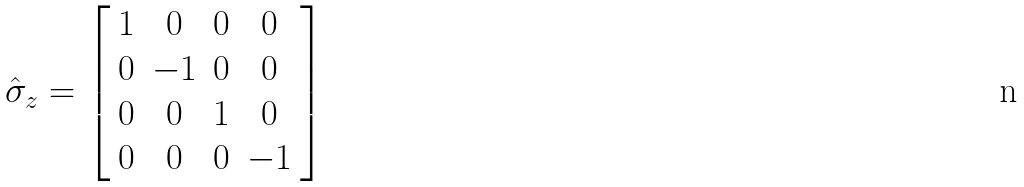Convert formula to latex. <formula><loc_0><loc_0><loc_500><loc_500>\hat { \sigma } _ { z } = \left [ \begin{array} { c c c c } 1 & 0 & 0 & 0 \\ 0 & - 1 & 0 & 0 \\ 0 & 0 & 1 & 0 \\ 0 & 0 & 0 & - 1 \end{array} \right ]</formula> 